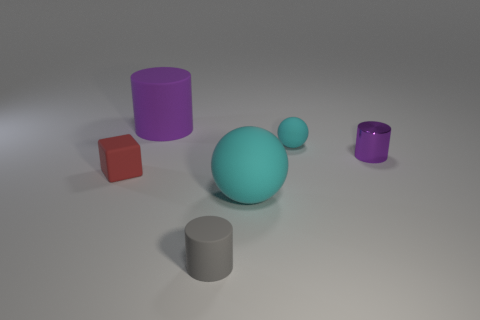What shapes are visible in the image? The image features a variety of basic three-dimensional shapes, including a sphere, cylinders, and cubes.  Do the objects share any common features? Yes, all objects have a smooth texture and showcase various solid colors, which may indicate they are perhaps part of a cohesive set or collection designed for a particular purpose, such as a visual demonstration. 